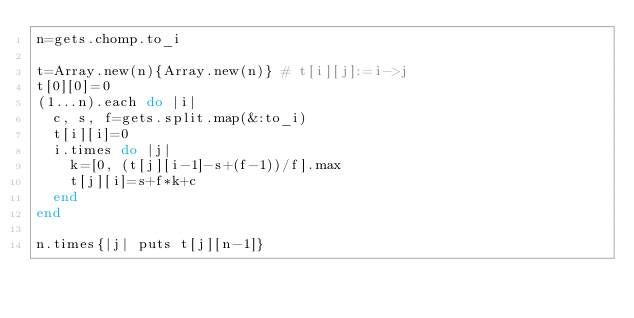<code> <loc_0><loc_0><loc_500><loc_500><_Ruby_>n=gets.chomp.to_i

t=Array.new(n){Array.new(n)} # t[i][j]:=i->j
t[0][0]=0
(1...n).each do |i|
  c, s, f=gets.split.map(&:to_i)
  t[i][i]=0
  i.times do |j|
    k=[0, (t[j][i-1]-s+(f-1))/f].max
    t[j][i]=s+f*k+c
  end
end

n.times{|j| puts t[j][n-1]}</code> 